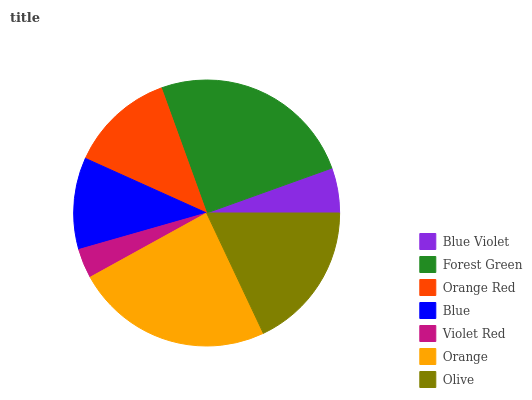Is Violet Red the minimum?
Answer yes or no. Yes. Is Forest Green the maximum?
Answer yes or no. Yes. Is Orange Red the minimum?
Answer yes or no. No. Is Orange Red the maximum?
Answer yes or no. No. Is Forest Green greater than Orange Red?
Answer yes or no. Yes. Is Orange Red less than Forest Green?
Answer yes or no. Yes. Is Orange Red greater than Forest Green?
Answer yes or no. No. Is Forest Green less than Orange Red?
Answer yes or no. No. Is Orange Red the high median?
Answer yes or no. Yes. Is Orange Red the low median?
Answer yes or no. Yes. Is Olive the high median?
Answer yes or no. No. Is Blue Violet the low median?
Answer yes or no. No. 